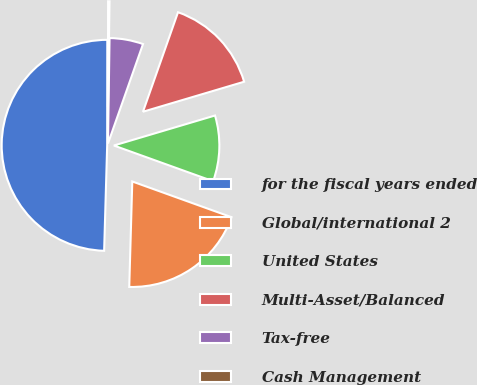Convert chart to OTSL. <chart><loc_0><loc_0><loc_500><loc_500><pie_chart><fcel>for the fiscal years ended<fcel>Global/international 2<fcel>United States<fcel>Multi-Asset/Balanced<fcel>Tax-free<fcel>Cash Management<nl><fcel>49.56%<fcel>19.96%<fcel>10.09%<fcel>15.02%<fcel>5.15%<fcel>0.22%<nl></chart> 